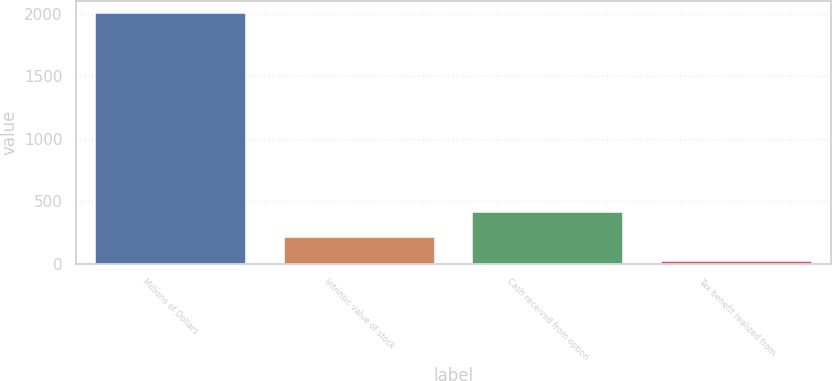Convert chart. <chart><loc_0><loc_0><loc_500><loc_500><bar_chart><fcel>Millions of Dollars<fcel>Intrinsic value of stock<fcel>Cash received from option<fcel>Tax benefit realized from<nl><fcel>2004<fcel>215.7<fcel>414.4<fcel>17<nl></chart> 